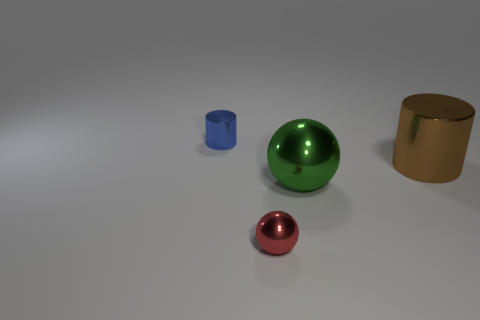Is there a large red object made of the same material as the blue cylinder?
Give a very brief answer. No. Is the material of the large object on the right side of the large metallic sphere the same as the tiny object behind the red sphere?
Make the answer very short. Yes. What number of small blue metal cylinders are there?
Keep it short and to the point. 1. There is a object that is behind the large cylinder; what is its shape?
Your answer should be compact. Cylinder. What number of other objects are there of the same size as the blue shiny cylinder?
Your answer should be compact. 1. There is a tiny thing behind the tiny metal ball; does it have the same shape as the small metal thing right of the tiny blue cylinder?
Provide a succinct answer. No. What number of big things are in front of the small red metal sphere?
Your answer should be compact. 0. There is a small thing left of the small shiny ball; what is its color?
Offer a very short reply. Blue. There is another metallic object that is the same shape as the large green metal thing; what is its color?
Offer a terse response. Red. Are there any other things that have the same color as the tiny sphere?
Provide a short and direct response. No. 